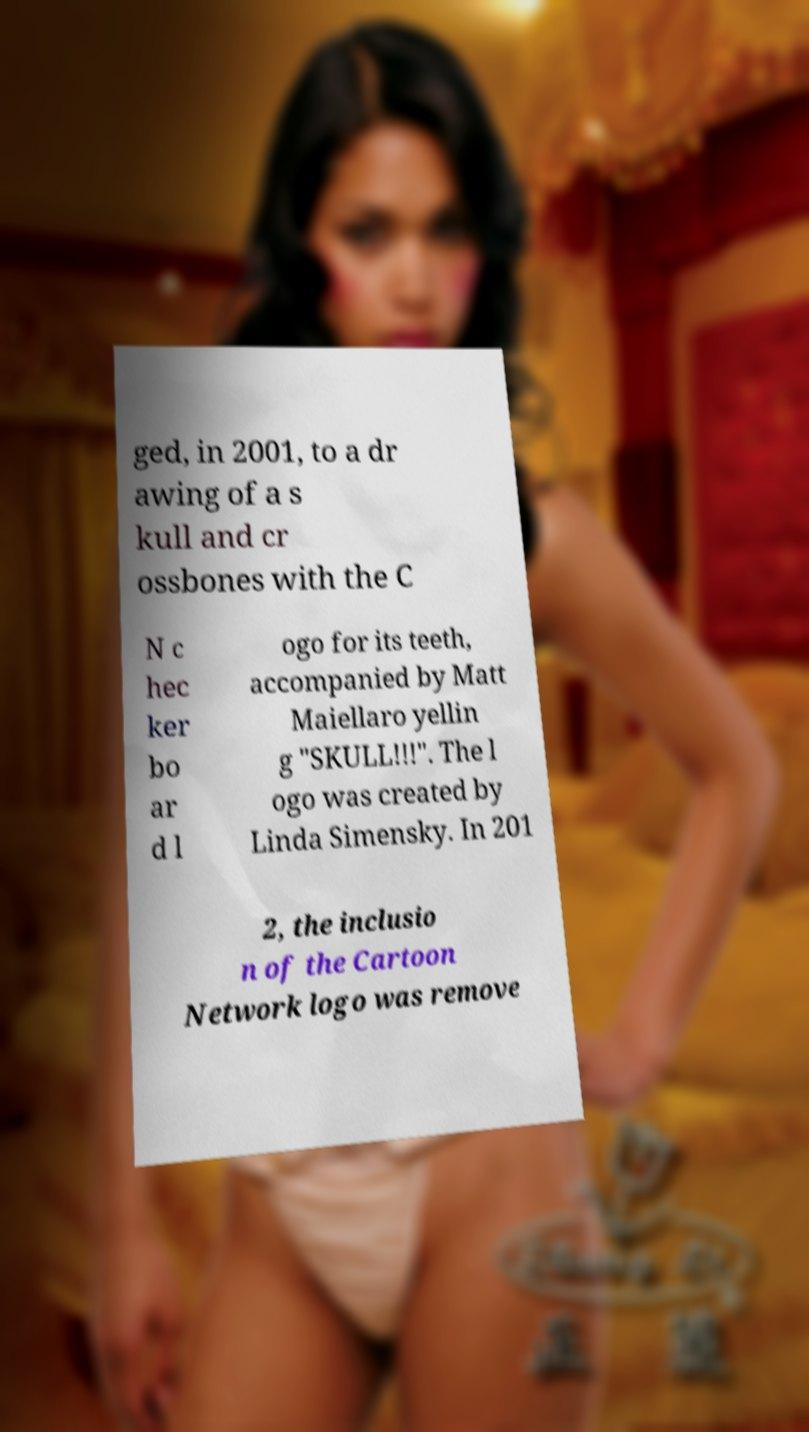For documentation purposes, I need the text within this image transcribed. Could you provide that? ged, in 2001, to a dr awing of a s kull and cr ossbones with the C N c hec ker bo ar d l ogo for its teeth, accompanied by Matt Maiellaro yellin g "SKULL!!!". The l ogo was created by Linda Simensky. In 201 2, the inclusio n of the Cartoon Network logo was remove 